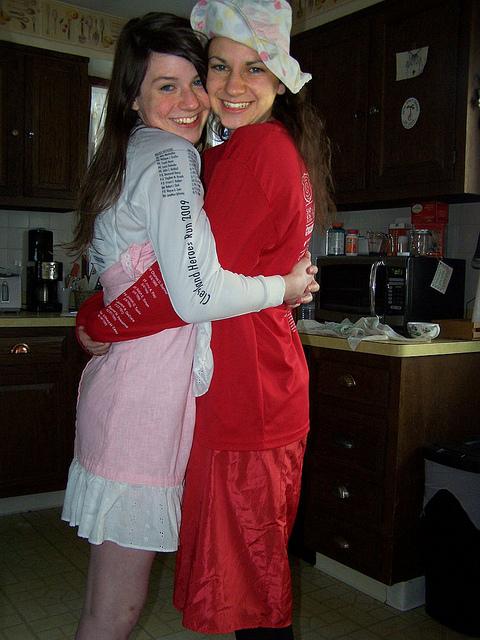Is this woman using a phone?
Be succinct. No. Where are those people at?
Write a very short answer. Kitchen. Are they close?
Be succinct. Yes. How many people are in the photo?
Concise answer only. 2. 